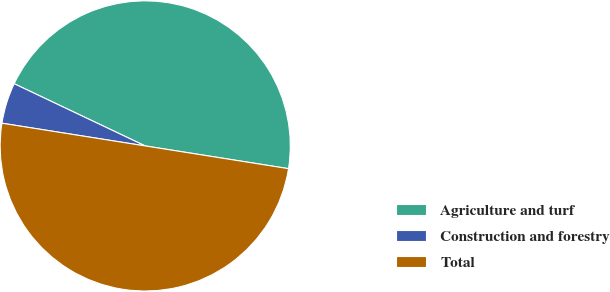Convert chart to OTSL. <chart><loc_0><loc_0><loc_500><loc_500><pie_chart><fcel>Agriculture and turf<fcel>Construction and forestry<fcel>Total<nl><fcel>45.45%<fcel>4.55%<fcel>50.0%<nl></chart> 